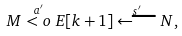Convert formula to latex. <formula><loc_0><loc_0><loc_500><loc_500>M \stackrel { a ^ { \prime } } { < o } E [ k + 1 ] \stackrel { s ^ { \prime } } { \longleftarrow } N ,</formula> 